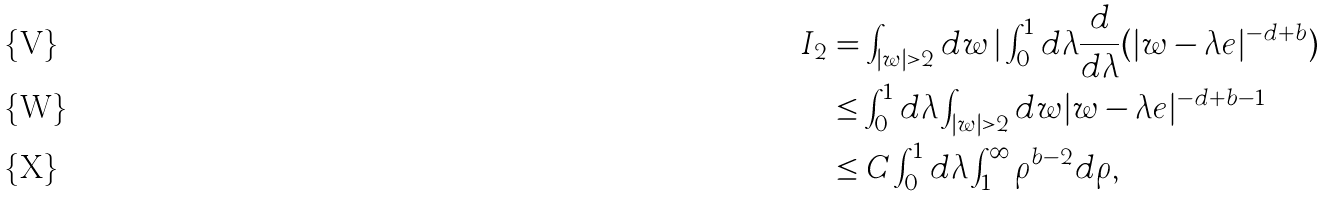Convert formula to latex. <formula><loc_0><loc_0><loc_500><loc_500>I _ { 2 } & = \int _ { | w | > 2 } d w \, | \int _ { 0 } ^ { 1 } d \lambda \frac { d } { d \lambda } ( | w - \lambda e | ^ { - d + b } ) \\ & \leq \int ^ { 1 } _ { 0 } d \lambda \int _ { | w | > 2 } d w | w - \lambda e | ^ { - d + b - 1 } \\ & \leq C \int ^ { 1 } _ { 0 } d \lambda \int _ { 1 } ^ { \infty } \rho ^ { b - 2 } d \rho ,</formula> 